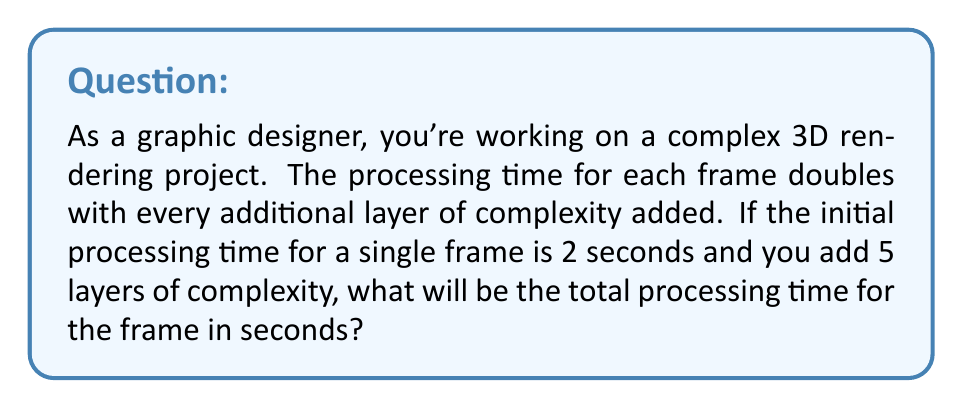Could you help me with this problem? Let's approach this step-by-step:

1) We start with an initial processing time of 2 seconds.

2) The processing time doubles with each layer of complexity. This is an exponential growth pattern.

3) We can represent this mathematically as:

   $T = T_0 \cdot 2^n$

   Where:
   $T$ is the final processing time
   $T_0$ is the initial processing time
   $n$ is the number of layers added

4) In this case:
   $T_0 = 2$ seconds
   $n = 5$ layers

5) Let's substitute these values into our formula:

   $T = 2 \cdot 2^5$

6) Now, let's calculate $2^5$:
   
   $2^5 = 2 \cdot 2 \cdot 2 \cdot 2 \cdot 2 = 32$

7) Therefore:

   $T = 2 \cdot 32 = 64$

Thus, the total processing time for the frame will be 64 seconds.
Answer: 64 seconds 